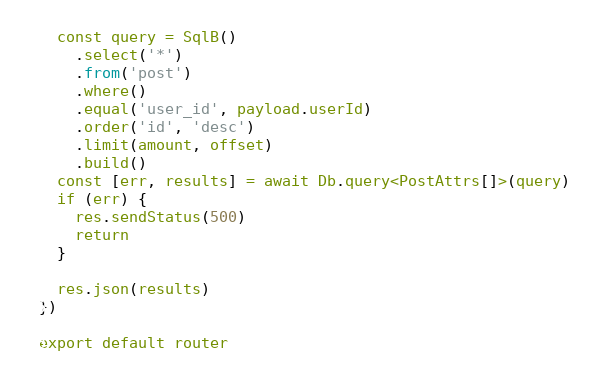Convert code to text. <code><loc_0><loc_0><loc_500><loc_500><_TypeScript_>  const query = SqlB()
    .select('*')
    .from('post')
    .where()
    .equal('user_id', payload.userId)
    .order('id', 'desc')
    .limit(amount, offset)
    .build()
  const [err, results] = await Db.query<PostAttrs[]>(query)
  if (err) {
    res.sendStatus(500)
    return
  }

  res.json(results)
})

export default router
</code> 